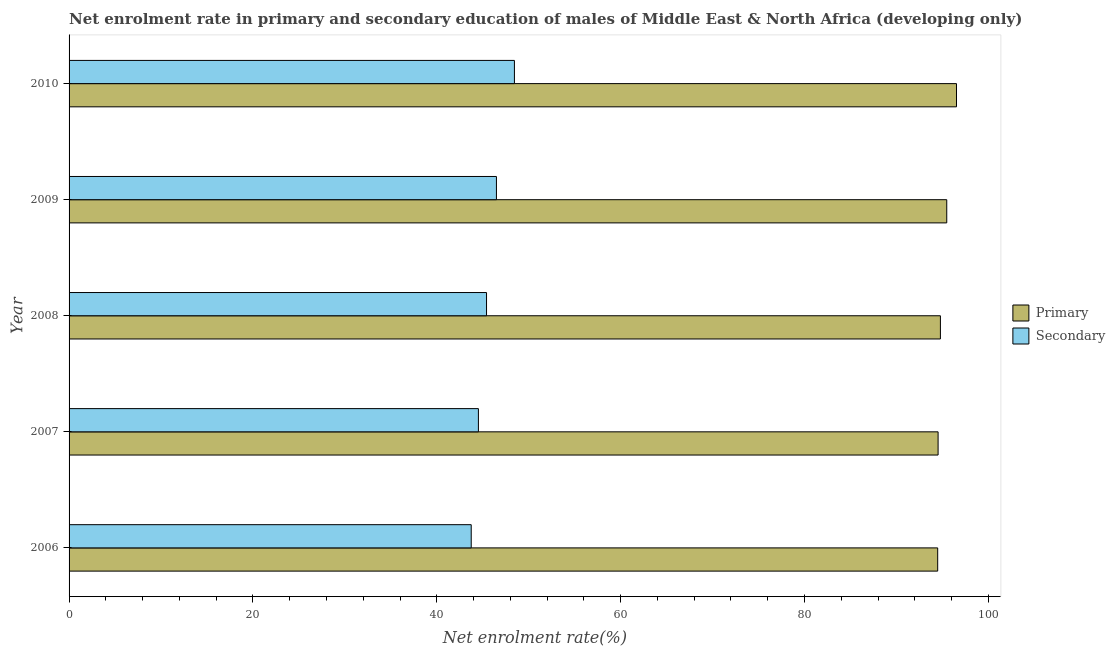How many different coloured bars are there?
Make the answer very short. 2. Are the number of bars on each tick of the Y-axis equal?
Offer a very short reply. Yes. How many bars are there on the 2nd tick from the top?
Provide a short and direct response. 2. In how many cases, is the number of bars for a given year not equal to the number of legend labels?
Your answer should be compact. 0. What is the enrollment rate in primary education in 2008?
Provide a short and direct response. 94.79. Across all years, what is the maximum enrollment rate in primary education?
Offer a terse response. 96.54. Across all years, what is the minimum enrollment rate in primary education?
Give a very brief answer. 94.49. What is the total enrollment rate in secondary education in the graph?
Offer a terse response. 228.62. What is the difference between the enrollment rate in primary education in 2008 and that in 2009?
Provide a succinct answer. -0.69. What is the difference between the enrollment rate in secondary education in 2008 and the enrollment rate in primary education in 2010?
Provide a short and direct response. -51.12. What is the average enrollment rate in primary education per year?
Your answer should be very brief. 95.17. In the year 2009, what is the difference between the enrollment rate in secondary education and enrollment rate in primary education?
Your answer should be compact. -48.99. What is the difference between the highest and the second highest enrollment rate in primary education?
Make the answer very short. 1.06. What is the difference between the highest and the lowest enrollment rate in primary education?
Make the answer very short. 2.05. Is the sum of the enrollment rate in primary education in 2007 and 2010 greater than the maximum enrollment rate in secondary education across all years?
Make the answer very short. Yes. What does the 2nd bar from the top in 2006 represents?
Offer a terse response. Primary. What does the 2nd bar from the bottom in 2006 represents?
Provide a succinct answer. Secondary. How many bars are there?
Ensure brevity in your answer.  10. Are the values on the major ticks of X-axis written in scientific E-notation?
Make the answer very short. No. What is the title of the graph?
Your response must be concise. Net enrolment rate in primary and secondary education of males of Middle East & North Africa (developing only). Does "Services" appear as one of the legend labels in the graph?
Offer a terse response. No. What is the label or title of the X-axis?
Your answer should be very brief. Net enrolment rate(%). What is the label or title of the Y-axis?
Provide a succinct answer. Year. What is the Net enrolment rate(%) in Primary in 2006?
Your response must be concise. 94.49. What is the Net enrolment rate(%) of Secondary in 2006?
Keep it short and to the point. 43.75. What is the Net enrolment rate(%) of Primary in 2007?
Give a very brief answer. 94.53. What is the Net enrolment rate(%) of Secondary in 2007?
Provide a succinct answer. 44.53. What is the Net enrolment rate(%) of Primary in 2008?
Provide a short and direct response. 94.79. What is the Net enrolment rate(%) of Secondary in 2008?
Offer a terse response. 45.41. What is the Net enrolment rate(%) of Primary in 2009?
Offer a terse response. 95.48. What is the Net enrolment rate(%) of Secondary in 2009?
Ensure brevity in your answer.  46.49. What is the Net enrolment rate(%) in Primary in 2010?
Keep it short and to the point. 96.54. What is the Net enrolment rate(%) of Secondary in 2010?
Give a very brief answer. 48.45. Across all years, what is the maximum Net enrolment rate(%) of Primary?
Offer a terse response. 96.54. Across all years, what is the maximum Net enrolment rate(%) in Secondary?
Provide a short and direct response. 48.45. Across all years, what is the minimum Net enrolment rate(%) in Primary?
Provide a short and direct response. 94.49. Across all years, what is the minimum Net enrolment rate(%) in Secondary?
Ensure brevity in your answer.  43.75. What is the total Net enrolment rate(%) in Primary in the graph?
Your answer should be compact. 475.82. What is the total Net enrolment rate(%) of Secondary in the graph?
Keep it short and to the point. 228.62. What is the difference between the Net enrolment rate(%) in Primary in 2006 and that in 2007?
Provide a succinct answer. -0.05. What is the difference between the Net enrolment rate(%) of Secondary in 2006 and that in 2007?
Make the answer very short. -0.78. What is the difference between the Net enrolment rate(%) of Primary in 2006 and that in 2008?
Your response must be concise. -0.3. What is the difference between the Net enrolment rate(%) of Secondary in 2006 and that in 2008?
Your response must be concise. -1.67. What is the difference between the Net enrolment rate(%) of Primary in 2006 and that in 2009?
Offer a very short reply. -0.99. What is the difference between the Net enrolment rate(%) of Secondary in 2006 and that in 2009?
Keep it short and to the point. -2.74. What is the difference between the Net enrolment rate(%) of Primary in 2006 and that in 2010?
Your answer should be compact. -2.05. What is the difference between the Net enrolment rate(%) of Secondary in 2006 and that in 2010?
Offer a very short reply. -4.7. What is the difference between the Net enrolment rate(%) of Primary in 2007 and that in 2008?
Keep it short and to the point. -0.25. What is the difference between the Net enrolment rate(%) in Secondary in 2007 and that in 2008?
Make the answer very short. -0.88. What is the difference between the Net enrolment rate(%) of Primary in 2007 and that in 2009?
Offer a very short reply. -0.94. What is the difference between the Net enrolment rate(%) in Secondary in 2007 and that in 2009?
Your answer should be very brief. -1.96. What is the difference between the Net enrolment rate(%) in Primary in 2007 and that in 2010?
Keep it short and to the point. -2. What is the difference between the Net enrolment rate(%) of Secondary in 2007 and that in 2010?
Keep it short and to the point. -3.92. What is the difference between the Net enrolment rate(%) in Primary in 2008 and that in 2009?
Keep it short and to the point. -0.69. What is the difference between the Net enrolment rate(%) in Secondary in 2008 and that in 2009?
Provide a short and direct response. -1.08. What is the difference between the Net enrolment rate(%) of Primary in 2008 and that in 2010?
Your answer should be compact. -1.75. What is the difference between the Net enrolment rate(%) in Secondary in 2008 and that in 2010?
Provide a short and direct response. -3.03. What is the difference between the Net enrolment rate(%) of Primary in 2009 and that in 2010?
Give a very brief answer. -1.06. What is the difference between the Net enrolment rate(%) of Secondary in 2009 and that in 2010?
Offer a very short reply. -1.96. What is the difference between the Net enrolment rate(%) of Primary in 2006 and the Net enrolment rate(%) of Secondary in 2007?
Ensure brevity in your answer.  49.96. What is the difference between the Net enrolment rate(%) in Primary in 2006 and the Net enrolment rate(%) in Secondary in 2008?
Make the answer very short. 49.08. What is the difference between the Net enrolment rate(%) in Primary in 2006 and the Net enrolment rate(%) in Secondary in 2009?
Your answer should be very brief. 48. What is the difference between the Net enrolment rate(%) of Primary in 2006 and the Net enrolment rate(%) of Secondary in 2010?
Your response must be concise. 46.04. What is the difference between the Net enrolment rate(%) of Primary in 2007 and the Net enrolment rate(%) of Secondary in 2008?
Your answer should be very brief. 49.12. What is the difference between the Net enrolment rate(%) of Primary in 2007 and the Net enrolment rate(%) of Secondary in 2009?
Your response must be concise. 48.05. What is the difference between the Net enrolment rate(%) of Primary in 2007 and the Net enrolment rate(%) of Secondary in 2010?
Offer a terse response. 46.09. What is the difference between the Net enrolment rate(%) in Primary in 2008 and the Net enrolment rate(%) in Secondary in 2009?
Provide a succinct answer. 48.3. What is the difference between the Net enrolment rate(%) of Primary in 2008 and the Net enrolment rate(%) of Secondary in 2010?
Offer a very short reply. 46.34. What is the difference between the Net enrolment rate(%) of Primary in 2009 and the Net enrolment rate(%) of Secondary in 2010?
Your answer should be compact. 47.03. What is the average Net enrolment rate(%) in Primary per year?
Offer a terse response. 95.16. What is the average Net enrolment rate(%) in Secondary per year?
Your answer should be very brief. 45.72. In the year 2006, what is the difference between the Net enrolment rate(%) of Primary and Net enrolment rate(%) of Secondary?
Your answer should be very brief. 50.74. In the year 2007, what is the difference between the Net enrolment rate(%) of Primary and Net enrolment rate(%) of Secondary?
Give a very brief answer. 50.01. In the year 2008, what is the difference between the Net enrolment rate(%) in Primary and Net enrolment rate(%) in Secondary?
Keep it short and to the point. 49.37. In the year 2009, what is the difference between the Net enrolment rate(%) of Primary and Net enrolment rate(%) of Secondary?
Offer a terse response. 48.99. In the year 2010, what is the difference between the Net enrolment rate(%) of Primary and Net enrolment rate(%) of Secondary?
Ensure brevity in your answer.  48.09. What is the ratio of the Net enrolment rate(%) of Primary in 2006 to that in 2007?
Ensure brevity in your answer.  1. What is the ratio of the Net enrolment rate(%) of Secondary in 2006 to that in 2007?
Provide a succinct answer. 0.98. What is the ratio of the Net enrolment rate(%) in Primary in 2006 to that in 2008?
Provide a short and direct response. 1. What is the ratio of the Net enrolment rate(%) in Secondary in 2006 to that in 2008?
Your answer should be compact. 0.96. What is the ratio of the Net enrolment rate(%) of Primary in 2006 to that in 2009?
Your answer should be very brief. 0.99. What is the ratio of the Net enrolment rate(%) of Secondary in 2006 to that in 2009?
Provide a succinct answer. 0.94. What is the ratio of the Net enrolment rate(%) of Primary in 2006 to that in 2010?
Offer a very short reply. 0.98. What is the ratio of the Net enrolment rate(%) of Secondary in 2006 to that in 2010?
Keep it short and to the point. 0.9. What is the ratio of the Net enrolment rate(%) in Secondary in 2007 to that in 2008?
Give a very brief answer. 0.98. What is the ratio of the Net enrolment rate(%) in Secondary in 2007 to that in 2009?
Ensure brevity in your answer.  0.96. What is the ratio of the Net enrolment rate(%) of Primary in 2007 to that in 2010?
Ensure brevity in your answer.  0.98. What is the ratio of the Net enrolment rate(%) of Secondary in 2007 to that in 2010?
Ensure brevity in your answer.  0.92. What is the ratio of the Net enrolment rate(%) of Primary in 2008 to that in 2009?
Your response must be concise. 0.99. What is the ratio of the Net enrolment rate(%) in Secondary in 2008 to that in 2009?
Your response must be concise. 0.98. What is the ratio of the Net enrolment rate(%) of Primary in 2008 to that in 2010?
Ensure brevity in your answer.  0.98. What is the ratio of the Net enrolment rate(%) in Secondary in 2008 to that in 2010?
Provide a succinct answer. 0.94. What is the ratio of the Net enrolment rate(%) of Secondary in 2009 to that in 2010?
Your answer should be compact. 0.96. What is the difference between the highest and the second highest Net enrolment rate(%) of Primary?
Your answer should be compact. 1.06. What is the difference between the highest and the second highest Net enrolment rate(%) of Secondary?
Your answer should be compact. 1.96. What is the difference between the highest and the lowest Net enrolment rate(%) of Primary?
Provide a succinct answer. 2.05. What is the difference between the highest and the lowest Net enrolment rate(%) in Secondary?
Your answer should be compact. 4.7. 